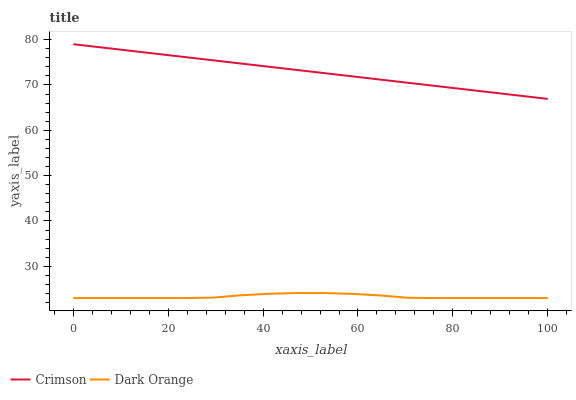Does Dark Orange have the minimum area under the curve?
Answer yes or no. Yes. Does Crimson have the maximum area under the curve?
Answer yes or no. Yes. Does Dark Orange have the maximum area under the curve?
Answer yes or no. No. Is Crimson the smoothest?
Answer yes or no. Yes. Is Dark Orange the roughest?
Answer yes or no. Yes. Is Dark Orange the smoothest?
Answer yes or no. No. Does Dark Orange have the lowest value?
Answer yes or no. Yes. Does Crimson have the highest value?
Answer yes or no. Yes. Does Dark Orange have the highest value?
Answer yes or no. No. Is Dark Orange less than Crimson?
Answer yes or no. Yes. Is Crimson greater than Dark Orange?
Answer yes or no. Yes. Does Dark Orange intersect Crimson?
Answer yes or no. No. 